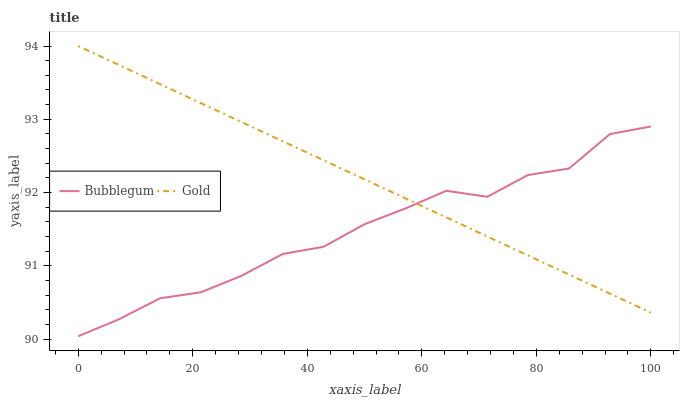Does Bubblegum have the minimum area under the curve?
Answer yes or no. Yes. Does Gold have the maximum area under the curve?
Answer yes or no. Yes. Does Bubblegum have the maximum area under the curve?
Answer yes or no. No. Is Gold the smoothest?
Answer yes or no. Yes. Is Bubblegum the roughest?
Answer yes or no. Yes. Is Bubblegum the smoothest?
Answer yes or no. No. Does Bubblegum have the lowest value?
Answer yes or no. Yes. Does Gold have the highest value?
Answer yes or no. Yes. Does Bubblegum have the highest value?
Answer yes or no. No. Does Gold intersect Bubblegum?
Answer yes or no. Yes. Is Gold less than Bubblegum?
Answer yes or no. No. Is Gold greater than Bubblegum?
Answer yes or no. No. 